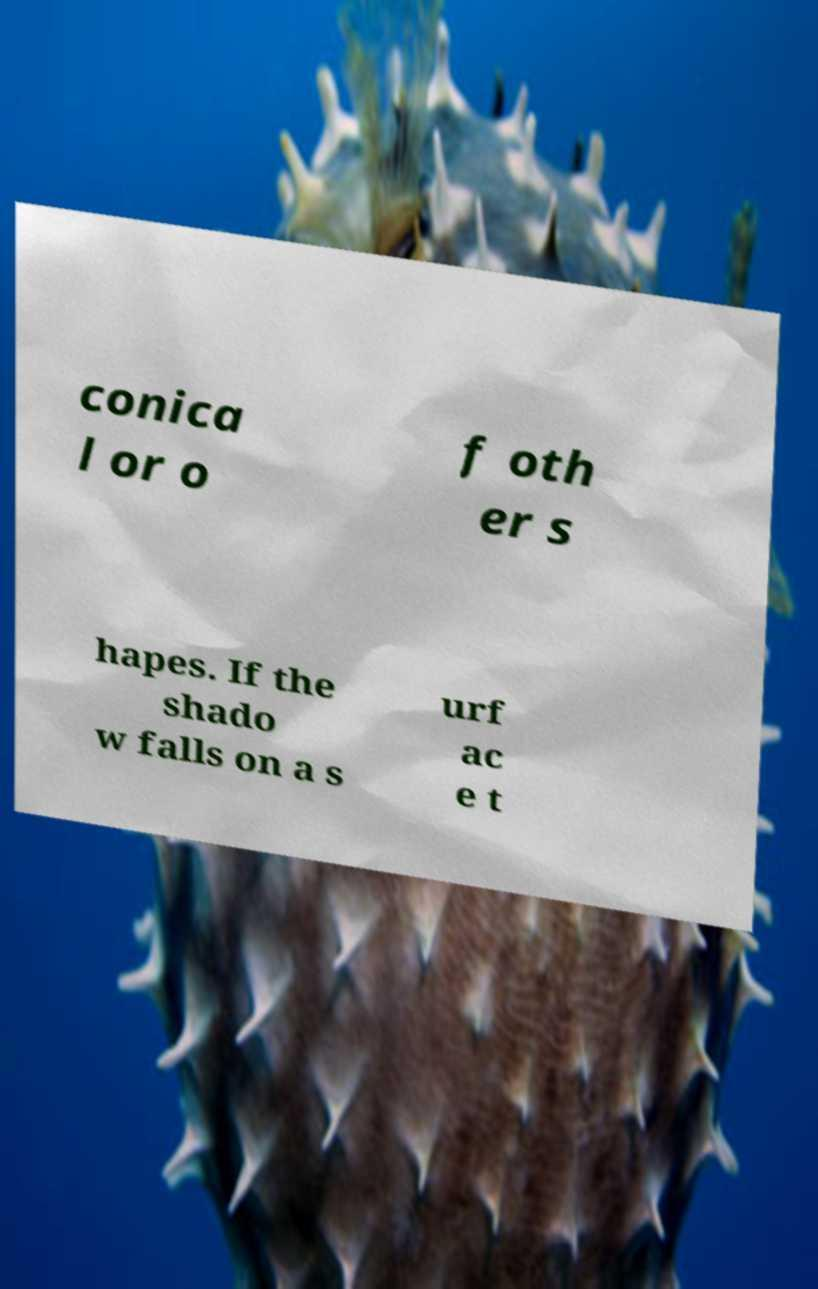There's text embedded in this image that I need extracted. Can you transcribe it verbatim? conica l or o f oth er s hapes. If the shado w falls on a s urf ac e t 